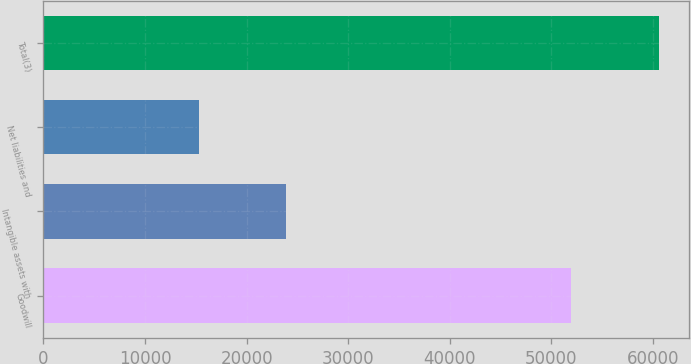Convert chart. <chart><loc_0><loc_0><loc_500><loc_500><bar_chart><fcel>Goodwill<fcel>Intangible assets with<fcel>Net liabilities and<fcel>Total(3)<nl><fcel>51947<fcel>23897<fcel>15283<fcel>60561<nl></chart> 